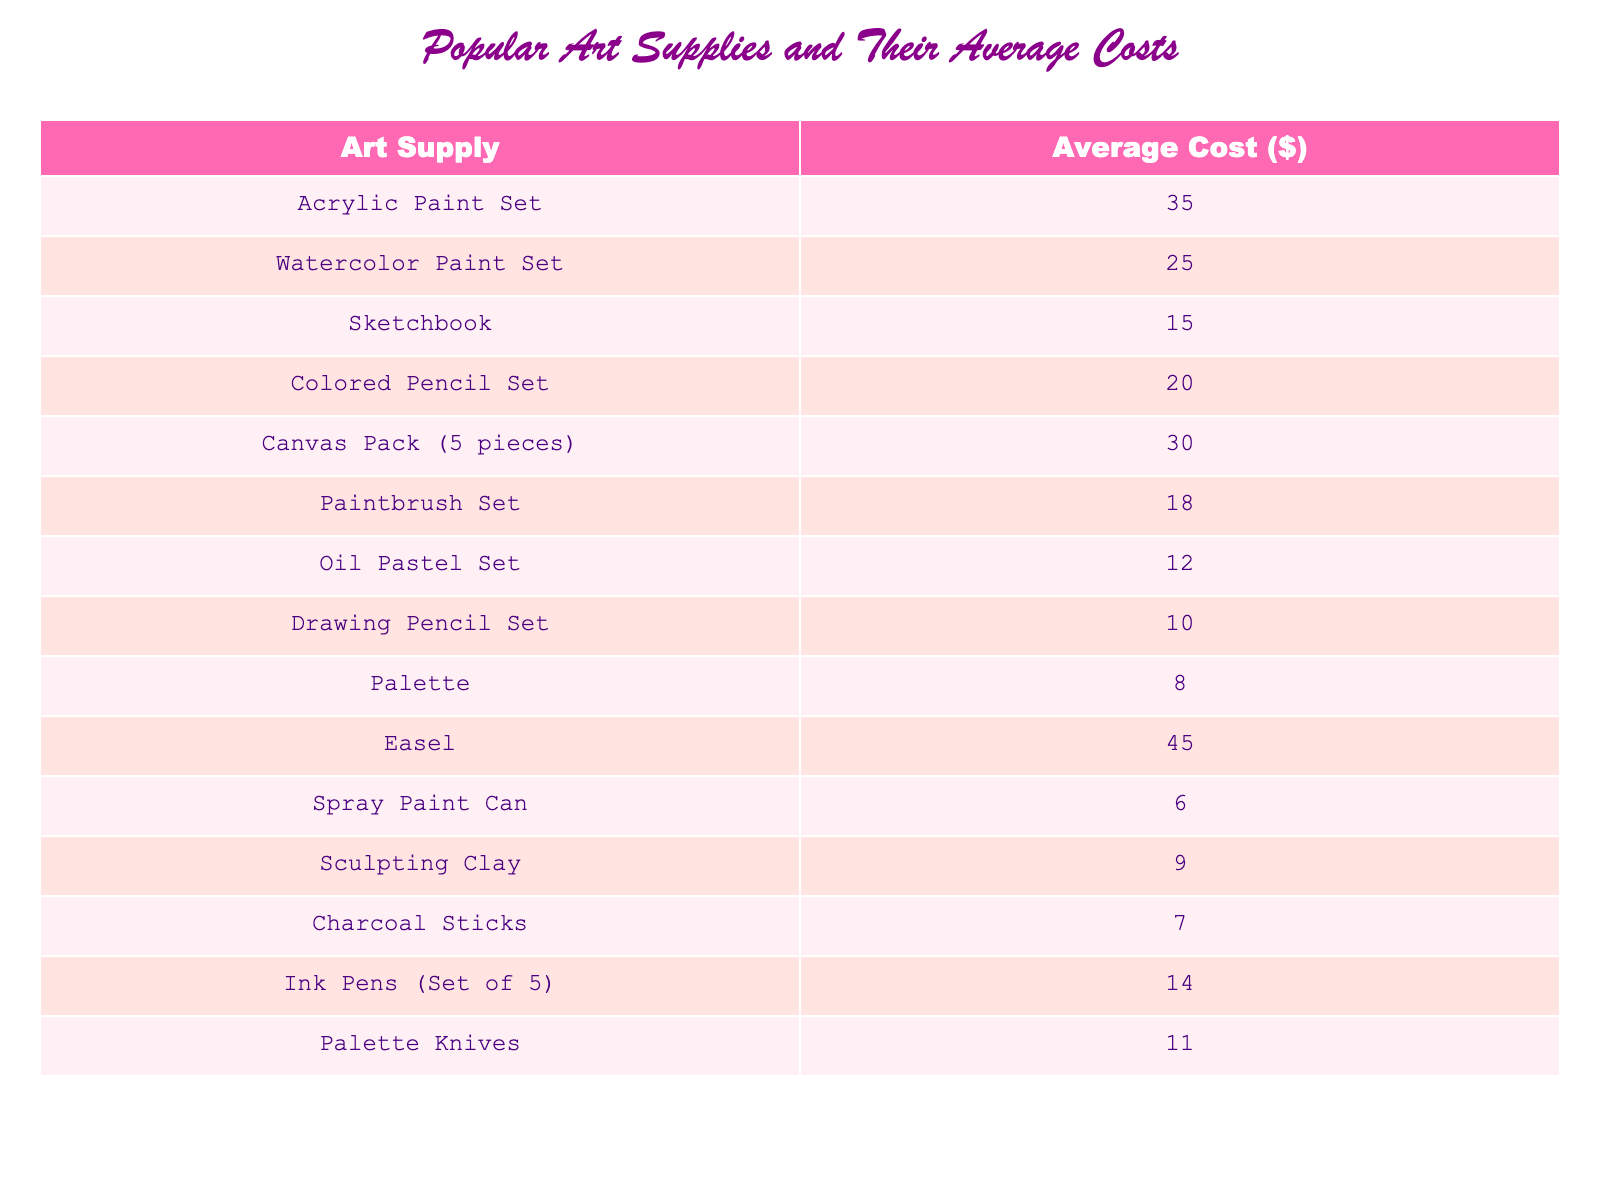What is the average cost of a Sketchbook? The table lists the average cost of a Sketchbook as $15.
Answer: 15 Which art supply is the most expensive? The table shows that the Easel has the highest average cost at $45.
Answer: Easel How much does a Palette cost? According to the table, the average cost of a Palette is $8.
Answer: 8 What is the total cost of a Colored Pencil Set and a Paintbrush Set? The Colored Pencil Set costs $20 and the Paintbrush Set costs $18. Adding these gives $20 + $18 = $38.
Answer: 38 How many art supplies cost less than $10? The table lists three supplies: Spray Paint Can ($6), Sculpting Clay ($9), and Charcoal Sticks ($7). Thus, there are 3 supplies.
Answer: 3 Is the average cost of a Watercolor Paint Set greater than that of Acrylic Paint Set? The average cost of a Watercolor Paint Set is $25, while the Acrylic Paint Set is $35, indicating that the Watercolor Paint Set is not greater.
Answer: No What is the difference in price between the most expensive art supply and the least expensive? The most expensive art supply is the Easel at $45, and the least expensive is the Spray Paint Can at $6. The difference is $45 - $6 = $39.
Answer: 39 If I buy 2 Canvas Packs, how much will it cost? Each Canvas Pack costs $30, so purchasing 2 will total $30 * 2 = $60.
Answer: 60 What is the average cost of the top three most expensive art supplies? The top three most expensive items are Easel ($45), Canvas Pack ($30), and Acrylic Paint Set ($35). The total cost is $45 + $30 + $35 = $110. Dividing by 3 gives an average of $110 / 3 = $36.67.
Answer: Approximately 36.67 Is there an art supply that costs exactly $20? Yes, the Colored Pencil Set is listed at exactly $20.
Answer: Yes 